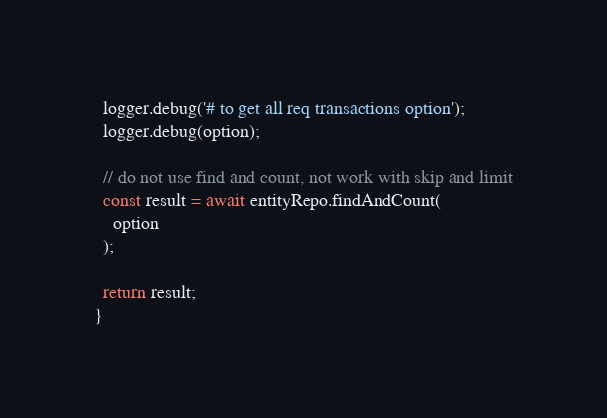Convert code to text. <code><loc_0><loc_0><loc_500><loc_500><_TypeScript_>  logger.debug('# to get all req transactions option');
  logger.debug(option);

  // do not use find and count, not work with skip and limit
  const result = await entityRepo.findAndCount(
    option
  );

  return result;
}
</code> 